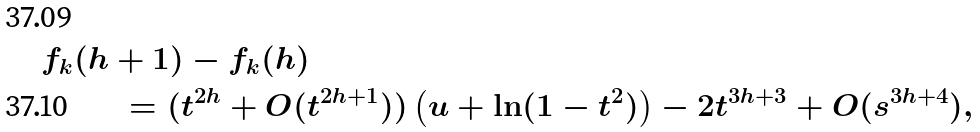<formula> <loc_0><loc_0><loc_500><loc_500>f _ { k } ( & h + 1 ) - f _ { k } ( h ) \\ & \quad = ( t ^ { 2 h } + O ( t ^ { 2 h + 1 } ) ) \left ( u + \ln ( 1 - t ^ { 2 } ) \right ) - 2 t ^ { 3 h + 3 } + O ( s ^ { 3 h + 4 } ) ,</formula> 